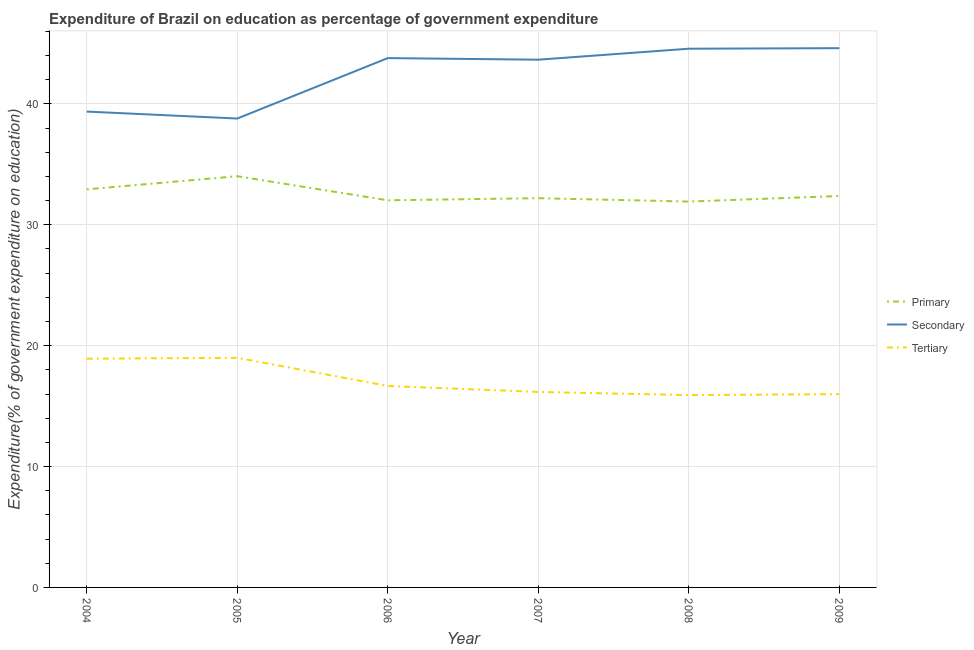What is the expenditure on secondary education in 2005?
Ensure brevity in your answer.  38.79. Across all years, what is the maximum expenditure on tertiary education?
Offer a very short reply. 19. Across all years, what is the minimum expenditure on tertiary education?
Give a very brief answer. 15.91. In which year was the expenditure on tertiary education maximum?
Provide a succinct answer. 2005. What is the total expenditure on primary education in the graph?
Provide a short and direct response. 195.47. What is the difference between the expenditure on primary education in 2005 and that in 2008?
Keep it short and to the point. 2.1. What is the difference between the expenditure on secondary education in 2004 and the expenditure on tertiary education in 2009?
Give a very brief answer. 23.37. What is the average expenditure on secondary education per year?
Offer a terse response. 42.46. In the year 2007, what is the difference between the expenditure on secondary education and expenditure on primary education?
Give a very brief answer. 11.46. What is the ratio of the expenditure on primary education in 2005 to that in 2008?
Offer a terse response. 1.07. Is the expenditure on primary education in 2004 less than that in 2008?
Provide a short and direct response. No. What is the difference between the highest and the second highest expenditure on primary education?
Make the answer very short. 1.08. What is the difference between the highest and the lowest expenditure on secondary education?
Provide a short and direct response. 5.82. In how many years, is the expenditure on secondary education greater than the average expenditure on secondary education taken over all years?
Offer a terse response. 4. Is it the case that in every year, the sum of the expenditure on primary education and expenditure on secondary education is greater than the expenditure on tertiary education?
Keep it short and to the point. Yes. Is the expenditure on tertiary education strictly greater than the expenditure on primary education over the years?
Provide a succinct answer. No. Is the expenditure on primary education strictly less than the expenditure on secondary education over the years?
Your answer should be compact. Yes. How many lines are there?
Keep it short and to the point. 3. How many years are there in the graph?
Your answer should be very brief. 6. Does the graph contain any zero values?
Your answer should be compact. No. How are the legend labels stacked?
Keep it short and to the point. Vertical. What is the title of the graph?
Give a very brief answer. Expenditure of Brazil on education as percentage of government expenditure. Does "Renewable sources" appear as one of the legend labels in the graph?
Your response must be concise. No. What is the label or title of the X-axis?
Your answer should be compact. Year. What is the label or title of the Y-axis?
Your response must be concise. Expenditure(% of government expenditure on education). What is the Expenditure(% of government expenditure on education) in Primary in 2004?
Ensure brevity in your answer.  32.93. What is the Expenditure(% of government expenditure on education) of Secondary in 2004?
Offer a terse response. 39.36. What is the Expenditure(% of government expenditure on education) of Tertiary in 2004?
Keep it short and to the point. 18.92. What is the Expenditure(% of government expenditure on education) in Primary in 2005?
Keep it short and to the point. 34.02. What is the Expenditure(% of government expenditure on education) of Secondary in 2005?
Your answer should be very brief. 38.79. What is the Expenditure(% of government expenditure on education) of Tertiary in 2005?
Provide a succinct answer. 19. What is the Expenditure(% of government expenditure on education) of Primary in 2006?
Offer a very short reply. 32.02. What is the Expenditure(% of government expenditure on education) of Secondary in 2006?
Ensure brevity in your answer.  43.79. What is the Expenditure(% of government expenditure on education) of Tertiary in 2006?
Ensure brevity in your answer.  16.66. What is the Expenditure(% of government expenditure on education) in Primary in 2007?
Ensure brevity in your answer.  32.2. What is the Expenditure(% of government expenditure on education) of Secondary in 2007?
Provide a short and direct response. 43.66. What is the Expenditure(% of government expenditure on education) of Tertiary in 2007?
Your response must be concise. 16.17. What is the Expenditure(% of government expenditure on education) in Primary in 2008?
Offer a terse response. 31.92. What is the Expenditure(% of government expenditure on education) of Secondary in 2008?
Give a very brief answer. 44.56. What is the Expenditure(% of government expenditure on education) of Tertiary in 2008?
Give a very brief answer. 15.91. What is the Expenditure(% of government expenditure on education) of Primary in 2009?
Your response must be concise. 32.38. What is the Expenditure(% of government expenditure on education) in Secondary in 2009?
Offer a terse response. 44.61. What is the Expenditure(% of government expenditure on education) in Tertiary in 2009?
Make the answer very short. 15.99. Across all years, what is the maximum Expenditure(% of government expenditure on education) in Primary?
Ensure brevity in your answer.  34.02. Across all years, what is the maximum Expenditure(% of government expenditure on education) of Secondary?
Keep it short and to the point. 44.61. Across all years, what is the maximum Expenditure(% of government expenditure on education) in Tertiary?
Provide a succinct answer. 19. Across all years, what is the minimum Expenditure(% of government expenditure on education) of Primary?
Offer a very short reply. 31.92. Across all years, what is the minimum Expenditure(% of government expenditure on education) in Secondary?
Offer a terse response. 38.79. Across all years, what is the minimum Expenditure(% of government expenditure on education) in Tertiary?
Your response must be concise. 15.91. What is the total Expenditure(% of government expenditure on education) of Primary in the graph?
Your response must be concise. 195.47. What is the total Expenditure(% of government expenditure on education) of Secondary in the graph?
Provide a short and direct response. 254.77. What is the total Expenditure(% of government expenditure on education) of Tertiary in the graph?
Provide a short and direct response. 102.65. What is the difference between the Expenditure(% of government expenditure on education) of Primary in 2004 and that in 2005?
Keep it short and to the point. -1.08. What is the difference between the Expenditure(% of government expenditure on education) in Secondary in 2004 and that in 2005?
Your answer should be compact. 0.57. What is the difference between the Expenditure(% of government expenditure on education) of Tertiary in 2004 and that in 2005?
Provide a short and direct response. -0.07. What is the difference between the Expenditure(% of government expenditure on education) in Primary in 2004 and that in 2006?
Offer a very short reply. 0.91. What is the difference between the Expenditure(% of government expenditure on education) in Secondary in 2004 and that in 2006?
Give a very brief answer. -4.42. What is the difference between the Expenditure(% of government expenditure on education) in Tertiary in 2004 and that in 2006?
Your answer should be compact. 2.26. What is the difference between the Expenditure(% of government expenditure on education) of Primary in 2004 and that in 2007?
Your answer should be very brief. 0.73. What is the difference between the Expenditure(% of government expenditure on education) in Secondary in 2004 and that in 2007?
Your answer should be very brief. -4.29. What is the difference between the Expenditure(% of government expenditure on education) of Tertiary in 2004 and that in 2007?
Offer a very short reply. 2.75. What is the difference between the Expenditure(% of government expenditure on education) in Primary in 2004 and that in 2008?
Keep it short and to the point. 1.01. What is the difference between the Expenditure(% of government expenditure on education) of Secondary in 2004 and that in 2008?
Offer a very short reply. -5.2. What is the difference between the Expenditure(% of government expenditure on education) in Tertiary in 2004 and that in 2008?
Provide a succinct answer. 3.01. What is the difference between the Expenditure(% of government expenditure on education) of Primary in 2004 and that in 2009?
Your answer should be compact. 0.55. What is the difference between the Expenditure(% of government expenditure on education) in Secondary in 2004 and that in 2009?
Provide a short and direct response. -5.25. What is the difference between the Expenditure(% of government expenditure on education) in Tertiary in 2004 and that in 2009?
Your answer should be very brief. 2.93. What is the difference between the Expenditure(% of government expenditure on education) in Primary in 2005 and that in 2006?
Provide a succinct answer. 1.99. What is the difference between the Expenditure(% of government expenditure on education) in Secondary in 2005 and that in 2006?
Offer a terse response. -5. What is the difference between the Expenditure(% of government expenditure on education) of Tertiary in 2005 and that in 2006?
Ensure brevity in your answer.  2.33. What is the difference between the Expenditure(% of government expenditure on education) of Primary in 2005 and that in 2007?
Provide a succinct answer. 1.82. What is the difference between the Expenditure(% of government expenditure on education) in Secondary in 2005 and that in 2007?
Keep it short and to the point. -4.87. What is the difference between the Expenditure(% of government expenditure on education) of Tertiary in 2005 and that in 2007?
Provide a short and direct response. 2.82. What is the difference between the Expenditure(% of government expenditure on education) in Primary in 2005 and that in 2008?
Ensure brevity in your answer.  2.1. What is the difference between the Expenditure(% of government expenditure on education) in Secondary in 2005 and that in 2008?
Offer a very short reply. -5.78. What is the difference between the Expenditure(% of government expenditure on education) in Tertiary in 2005 and that in 2008?
Make the answer very short. 3.08. What is the difference between the Expenditure(% of government expenditure on education) of Primary in 2005 and that in 2009?
Provide a short and direct response. 1.64. What is the difference between the Expenditure(% of government expenditure on education) of Secondary in 2005 and that in 2009?
Provide a short and direct response. -5.82. What is the difference between the Expenditure(% of government expenditure on education) of Tertiary in 2005 and that in 2009?
Your answer should be very brief. 3.01. What is the difference between the Expenditure(% of government expenditure on education) in Primary in 2006 and that in 2007?
Make the answer very short. -0.17. What is the difference between the Expenditure(% of government expenditure on education) in Secondary in 2006 and that in 2007?
Give a very brief answer. 0.13. What is the difference between the Expenditure(% of government expenditure on education) in Tertiary in 2006 and that in 2007?
Your answer should be very brief. 0.49. What is the difference between the Expenditure(% of government expenditure on education) in Primary in 2006 and that in 2008?
Your response must be concise. 0.11. What is the difference between the Expenditure(% of government expenditure on education) of Secondary in 2006 and that in 2008?
Provide a succinct answer. -0.78. What is the difference between the Expenditure(% of government expenditure on education) in Tertiary in 2006 and that in 2008?
Ensure brevity in your answer.  0.75. What is the difference between the Expenditure(% of government expenditure on education) of Primary in 2006 and that in 2009?
Your answer should be very brief. -0.35. What is the difference between the Expenditure(% of government expenditure on education) of Secondary in 2006 and that in 2009?
Make the answer very short. -0.82. What is the difference between the Expenditure(% of government expenditure on education) of Tertiary in 2006 and that in 2009?
Keep it short and to the point. 0.68. What is the difference between the Expenditure(% of government expenditure on education) in Primary in 2007 and that in 2008?
Offer a very short reply. 0.28. What is the difference between the Expenditure(% of government expenditure on education) of Secondary in 2007 and that in 2008?
Keep it short and to the point. -0.91. What is the difference between the Expenditure(% of government expenditure on education) in Tertiary in 2007 and that in 2008?
Ensure brevity in your answer.  0.26. What is the difference between the Expenditure(% of government expenditure on education) of Primary in 2007 and that in 2009?
Keep it short and to the point. -0.18. What is the difference between the Expenditure(% of government expenditure on education) of Secondary in 2007 and that in 2009?
Offer a very short reply. -0.95. What is the difference between the Expenditure(% of government expenditure on education) in Tertiary in 2007 and that in 2009?
Your answer should be very brief. 0.18. What is the difference between the Expenditure(% of government expenditure on education) of Primary in 2008 and that in 2009?
Give a very brief answer. -0.46. What is the difference between the Expenditure(% of government expenditure on education) of Secondary in 2008 and that in 2009?
Provide a succinct answer. -0.04. What is the difference between the Expenditure(% of government expenditure on education) in Tertiary in 2008 and that in 2009?
Offer a terse response. -0.08. What is the difference between the Expenditure(% of government expenditure on education) of Primary in 2004 and the Expenditure(% of government expenditure on education) of Secondary in 2005?
Ensure brevity in your answer.  -5.86. What is the difference between the Expenditure(% of government expenditure on education) in Primary in 2004 and the Expenditure(% of government expenditure on education) in Tertiary in 2005?
Offer a very short reply. 13.94. What is the difference between the Expenditure(% of government expenditure on education) of Secondary in 2004 and the Expenditure(% of government expenditure on education) of Tertiary in 2005?
Provide a short and direct response. 20.37. What is the difference between the Expenditure(% of government expenditure on education) in Primary in 2004 and the Expenditure(% of government expenditure on education) in Secondary in 2006?
Give a very brief answer. -10.86. What is the difference between the Expenditure(% of government expenditure on education) of Primary in 2004 and the Expenditure(% of government expenditure on education) of Tertiary in 2006?
Offer a terse response. 16.27. What is the difference between the Expenditure(% of government expenditure on education) of Secondary in 2004 and the Expenditure(% of government expenditure on education) of Tertiary in 2006?
Your answer should be compact. 22.7. What is the difference between the Expenditure(% of government expenditure on education) in Primary in 2004 and the Expenditure(% of government expenditure on education) in Secondary in 2007?
Offer a very short reply. -10.72. What is the difference between the Expenditure(% of government expenditure on education) of Primary in 2004 and the Expenditure(% of government expenditure on education) of Tertiary in 2007?
Ensure brevity in your answer.  16.76. What is the difference between the Expenditure(% of government expenditure on education) in Secondary in 2004 and the Expenditure(% of government expenditure on education) in Tertiary in 2007?
Make the answer very short. 23.19. What is the difference between the Expenditure(% of government expenditure on education) in Primary in 2004 and the Expenditure(% of government expenditure on education) in Secondary in 2008?
Offer a terse response. -11.63. What is the difference between the Expenditure(% of government expenditure on education) of Primary in 2004 and the Expenditure(% of government expenditure on education) of Tertiary in 2008?
Keep it short and to the point. 17.02. What is the difference between the Expenditure(% of government expenditure on education) in Secondary in 2004 and the Expenditure(% of government expenditure on education) in Tertiary in 2008?
Your response must be concise. 23.45. What is the difference between the Expenditure(% of government expenditure on education) of Primary in 2004 and the Expenditure(% of government expenditure on education) of Secondary in 2009?
Your response must be concise. -11.68. What is the difference between the Expenditure(% of government expenditure on education) of Primary in 2004 and the Expenditure(% of government expenditure on education) of Tertiary in 2009?
Offer a terse response. 16.94. What is the difference between the Expenditure(% of government expenditure on education) of Secondary in 2004 and the Expenditure(% of government expenditure on education) of Tertiary in 2009?
Your answer should be very brief. 23.37. What is the difference between the Expenditure(% of government expenditure on education) of Primary in 2005 and the Expenditure(% of government expenditure on education) of Secondary in 2006?
Make the answer very short. -9.77. What is the difference between the Expenditure(% of government expenditure on education) of Primary in 2005 and the Expenditure(% of government expenditure on education) of Tertiary in 2006?
Ensure brevity in your answer.  17.35. What is the difference between the Expenditure(% of government expenditure on education) in Secondary in 2005 and the Expenditure(% of government expenditure on education) in Tertiary in 2006?
Your answer should be very brief. 22.12. What is the difference between the Expenditure(% of government expenditure on education) of Primary in 2005 and the Expenditure(% of government expenditure on education) of Secondary in 2007?
Your answer should be very brief. -9.64. What is the difference between the Expenditure(% of government expenditure on education) of Primary in 2005 and the Expenditure(% of government expenditure on education) of Tertiary in 2007?
Your answer should be compact. 17.84. What is the difference between the Expenditure(% of government expenditure on education) of Secondary in 2005 and the Expenditure(% of government expenditure on education) of Tertiary in 2007?
Keep it short and to the point. 22.62. What is the difference between the Expenditure(% of government expenditure on education) in Primary in 2005 and the Expenditure(% of government expenditure on education) in Secondary in 2008?
Make the answer very short. -10.55. What is the difference between the Expenditure(% of government expenditure on education) in Primary in 2005 and the Expenditure(% of government expenditure on education) in Tertiary in 2008?
Offer a terse response. 18.11. What is the difference between the Expenditure(% of government expenditure on education) of Secondary in 2005 and the Expenditure(% of government expenditure on education) of Tertiary in 2008?
Offer a very short reply. 22.88. What is the difference between the Expenditure(% of government expenditure on education) of Primary in 2005 and the Expenditure(% of government expenditure on education) of Secondary in 2009?
Provide a succinct answer. -10.59. What is the difference between the Expenditure(% of government expenditure on education) in Primary in 2005 and the Expenditure(% of government expenditure on education) in Tertiary in 2009?
Make the answer very short. 18.03. What is the difference between the Expenditure(% of government expenditure on education) of Secondary in 2005 and the Expenditure(% of government expenditure on education) of Tertiary in 2009?
Your response must be concise. 22.8. What is the difference between the Expenditure(% of government expenditure on education) of Primary in 2006 and the Expenditure(% of government expenditure on education) of Secondary in 2007?
Your answer should be very brief. -11.63. What is the difference between the Expenditure(% of government expenditure on education) in Primary in 2006 and the Expenditure(% of government expenditure on education) in Tertiary in 2007?
Provide a succinct answer. 15.85. What is the difference between the Expenditure(% of government expenditure on education) in Secondary in 2006 and the Expenditure(% of government expenditure on education) in Tertiary in 2007?
Ensure brevity in your answer.  27.62. What is the difference between the Expenditure(% of government expenditure on education) in Primary in 2006 and the Expenditure(% of government expenditure on education) in Secondary in 2008?
Make the answer very short. -12.54. What is the difference between the Expenditure(% of government expenditure on education) in Primary in 2006 and the Expenditure(% of government expenditure on education) in Tertiary in 2008?
Your answer should be compact. 16.11. What is the difference between the Expenditure(% of government expenditure on education) of Secondary in 2006 and the Expenditure(% of government expenditure on education) of Tertiary in 2008?
Offer a terse response. 27.88. What is the difference between the Expenditure(% of government expenditure on education) in Primary in 2006 and the Expenditure(% of government expenditure on education) in Secondary in 2009?
Give a very brief answer. -12.58. What is the difference between the Expenditure(% of government expenditure on education) of Primary in 2006 and the Expenditure(% of government expenditure on education) of Tertiary in 2009?
Keep it short and to the point. 16.04. What is the difference between the Expenditure(% of government expenditure on education) of Secondary in 2006 and the Expenditure(% of government expenditure on education) of Tertiary in 2009?
Offer a terse response. 27.8. What is the difference between the Expenditure(% of government expenditure on education) in Primary in 2007 and the Expenditure(% of government expenditure on education) in Secondary in 2008?
Your answer should be very brief. -12.37. What is the difference between the Expenditure(% of government expenditure on education) in Primary in 2007 and the Expenditure(% of government expenditure on education) in Tertiary in 2008?
Offer a very short reply. 16.29. What is the difference between the Expenditure(% of government expenditure on education) in Secondary in 2007 and the Expenditure(% of government expenditure on education) in Tertiary in 2008?
Provide a succinct answer. 27.75. What is the difference between the Expenditure(% of government expenditure on education) of Primary in 2007 and the Expenditure(% of government expenditure on education) of Secondary in 2009?
Make the answer very short. -12.41. What is the difference between the Expenditure(% of government expenditure on education) in Primary in 2007 and the Expenditure(% of government expenditure on education) in Tertiary in 2009?
Provide a succinct answer. 16.21. What is the difference between the Expenditure(% of government expenditure on education) of Secondary in 2007 and the Expenditure(% of government expenditure on education) of Tertiary in 2009?
Give a very brief answer. 27.67. What is the difference between the Expenditure(% of government expenditure on education) in Primary in 2008 and the Expenditure(% of government expenditure on education) in Secondary in 2009?
Ensure brevity in your answer.  -12.69. What is the difference between the Expenditure(% of government expenditure on education) in Primary in 2008 and the Expenditure(% of government expenditure on education) in Tertiary in 2009?
Provide a short and direct response. 15.93. What is the difference between the Expenditure(% of government expenditure on education) of Secondary in 2008 and the Expenditure(% of government expenditure on education) of Tertiary in 2009?
Provide a short and direct response. 28.58. What is the average Expenditure(% of government expenditure on education) in Primary per year?
Offer a terse response. 32.58. What is the average Expenditure(% of government expenditure on education) of Secondary per year?
Make the answer very short. 42.46. What is the average Expenditure(% of government expenditure on education) of Tertiary per year?
Give a very brief answer. 17.11. In the year 2004, what is the difference between the Expenditure(% of government expenditure on education) in Primary and Expenditure(% of government expenditure on education) in Secondary?
Make the answer very short. -6.43. In the year 2004, what is the difference between the Expenditure(% of government expenditure on education) of Primary and Expenditure(% of government expenditure on education) of Tertiary?
Offer a terse response. 14.01. In the year 2004, what is the difference between the Expenditure(% of government expenditure on education) of Secondary and Expenditure(% of government expenditure on education) of Tertiary?
Your answer should be compact. 20.44. In the year 2005, what is the difference between the Expenditure(% of government expenditure on education) of Primary and Expenditure(% of government expenditure on education) of Secondary?
Provide a succinct answer. -4.77. In the year 2005, what is the difference between the Expenditure(% of government expenditure on education) in Primary and Expenditure(% of government expenditure on education) in Tertiary?
Your response must be concise. 15.02. In the year 2005, what is the difference between the Expenditure(% of government expenditure on education) of Secondary and Expenditure(% of government expenditure on education) of Tertiary?
Your answer should be very brief. 19.79. In the year 2006, what is the difference between the Expenditure(% of government expenditure on education) in Primary and Expenditure(% of government expenditure on education) in Secondary?
Provide a short and direct response. -11.76. In the year 2006, what is the difference between the Expenditure(% of government expenditure on education) in Primary and Expenditure(% of government expenditure on education) in Tertiary?
Make the answer very short. 15.36. In the year 2006, what is the difference between the Expenditure(% of government expenditure on education) in Secondary and Expenditure(% of government expenditure on education) in Tertiary?
Make the answer very short. 27.12. In the year 2007, what is the difference between the Expenditure(% of government expenditure on education) in Primary and Expenditure(% of government expenditure on education) in Secondary?
Your answer should be very brief. -11.46. In the year 2007, what is the difference between the Expenditure(% of government expenditure on education) of Primary and Expenditure(% of government expenditure on education) of Tertiary?
Provide a succinct answer. 16.03. In the year 2007, what is the difference between the Expenditure(% of government expenditure on education) of Secondary and Expenditure(% of government expenditure on education) of Tertiary?
Provide a short and direct response. 27.48. In the year 2008, what is the difference between the Expenditure(% of government expenditure on education) in Primary and Expenditure(% of government expenditure on education) in Secondary?
Keep it short and to the point. -12.64. In the year 2008, what is the difference between the Expenditure(% of government expenditure on education) of Primary and Expenditure(% of government expenditure on education) of Tertiary?
Your response must be concise. 16.01. In the year 2008, what is the difference between the Expenditure(% of government expenditure on education) in Secondary and Expenditure(% of government expenditure on education) in Tertiary?
Keep it short and to the point. 28.65. In the year 2009, what is the difference between the Expenditure(% of government expenditure on education) in Primary and Expenditure(% of government expenditure on education) in Secondary?
Your answer should be compact. -12.23. In the year 2009, what is the difference between the Expenditure(% of government expenditure on education) of Primary and Expenditure(% of government expenditure on education) of Tertiary?
Offer a terse response. 16.39. In the year 2009, what is the difference between the Expenditure(% of government expenditure on education) of Secondary and Expenditure(% of government expenditure on education) of Tertiary?
Keep it short and to the point. 28.62. What is the ratio of the Expenditure(% of government expenditure on education) in Primary in 2004 to that in 2005?
Your answer should be very brief. 0.97. What is the ratio of the Expenditure(% of government expenditure on education) of Secondary in 2004 to that in 2005?
Ensure brevity in your answer.  1.01. What is the ratio of the Expenditure(% of government expenditure on education) in Primary in 2004 to that in 2006?
Ensure brevity in your answer.  1.03. What is the ratio of the Expenditure(% of government expenditure on education) in Secondary in 2004 to that in 2006?
Offer a terse response. 0.9. What is the ratio of the Expenditure(% of government expenditure on education) of Tertiary in 2004 to that in 2006?
Ensure brevity in your answer.  1.14. What is the ratio of the Expenditure(% of government expenditure on education) of Primary in 2004 to that in 2007?
Offer a very short reply. 1.02. What is the ratio of the Expenditure(% of government expenditure on education) in Secondary in 2004 to that in 2007?
Ensure brevity in your answer.  0.9. What is the ratio of the Expenditure(% of government expenditure on education) in Tertiary in 2004 to that in 2007?
Give a very brief answer. 1.17. What is the ratio of the Expenditure(% of government expenditure on education) of Primary in 2004 to that in 2008?
Provide a succinct answer. 1.03. What is the ratio of the Expenditure(% of government expenditure on education) in Secondary in 2004 to that in 2008?
Offer a very short reply. 0.88. What is the ratio of the Expenditure(% of government expenditure on education) of Tertiary in 2004 to that in 2008?
Provide a succinct answer. 1.19. What is the ratio of the Expenditure(% of government expenditure on education) of Primary in 2004 to that in 2009?
Offer a terse response. 1.02. What is the ratio of the Expenditure(% of government expenditure on education) in Secondary in 2004 to that in 2009?
Give a very brief answer. 0.88. What is the ratio of the Expenditure(% of government expenditure on education) of Tertiary in 2004 to that in 2009?
Offer a terse response. 1.18. What is the ratio of the Expenditure(% of government expenditure on education) in Primary in 2005 to that in 2006?
Provide a succinct answer. 1.06. What is the ratio of the Expenditure(% of government expenditure on education) in Secondary in 2005 to that in 2006?
Provide a short and direct response. 0.89. What is the ratio of the Expenditure(% of government expenditure on education) in Tertiary in 2005 to that in 2006?
Give a very brief answer. 1.14. What is the ratio of the Expenditure(% of government expenditure on education) in Primary in 2005 to that in 2007?
Provide a short and direct response. 1.06. What is the ratio of the Expenditure(% of government expenditure on education) of Secondary in 2005 to that in 2007?
Provide a succinct answer. 0.89. What is the ratio of the Expenditure(% of government expenditure on education) in Tertiary in 2005 to that in 2007?
Give a very brief answer. 1.17. What is the ratio of the Expenditure(% of government expenditure on education) in Primary in 2005 to that in 2008?
Offer a very short reply. 1.07. What is the ratio of the Expenditure(% of government expenditure on education) in Secondary in 2005 to that in 2008?
Offer a terse response. 0.87. What is the ratio of the Expenditure(% of government expenditure on education) in Tertiary in 2005 to that in 2008?
Keep it short and to the point. 1.19. What is the ratio of the Expenditure(% of government expenditure on education) in Primary in 2005 to that in 2009?
Your answer should be compact. 1.05. What is the ratio of the Expenditure(% of government expenditure on education) of Secondary in 2005 to that in 2009?
Keep it short and to the point. 0.87. What is the ratio of the Expenditure(% of government expenditure on education) in Tertiary in 2005 to that in 2009?
Offer a very short reply. 1.19. What is the ratio of the Expenditure(% of government expenditure on education) in Primary in 2006 to that in 2007?
Keep it short and to the point. 0.99. What is the ratio of the Expenditure(% of government expenditure on education) of Tertiary in 2006 to that in 2007?
Keep it short and to the point. 1.03. What is the ratio of the Expenditure(% of government expenditure on education) of Primary in 2006 to that in 2008?
Your response must be concise. 1. What is the ratio of the Expenditure(% of government expenditure on education) in Secondary in 2006 to that in 2008?
Offer a terse response. 0.98. What is the ratio of the Expenditure(% of government expenditure on education) in Tertiary in 2006 to that in 2008?
Your response must be concise. 1.05. What is the ratio of the Expenditure(% of government expenditure on education) in Primary in 2006 to that in 2009?
Your answer should be compact. 0.99. What is the ratio of the Expenditure(% of government expenditure on education) in Secondary in 2006 to that in 2009?
Your answer should be compact. 0.98. What is the ratio of the Expenditure(% of government expenditure on education) of Tertiary in 2006 to that in 2009?
Provide a succinct answer. 1.04. What is the ratio of the Expenditure(% of government expenditure on education) of Primary in 2007 to that in 2008?
Provide a succinct answer. 1.01. What is the ratio of the Expenditure(% of government expenditure on education) of Secondary in 2007 to that in 2008?
Your answer should be very brief. 0.98. What is the ratio of the Expenditure(% of government expenditure on education) in Tertiary in 2007 to that in 2008?
Offer a terse response. 1.02. What is the ratio of the Expenditure(% of government expenditure on education) of Primary in 2007 to that in 2009?
Give a very brief answer. 0.99. What is the ratio of the Expenditure(% of government expenditure on education) in Secondary in 2007 to that in 2009?
Your answer should be compact. 0.98. What is the ratio of the Expenditure(% of government expenditure on education) in Tertiary in 2007 to that in 2009?
Provide a short and direct response. 1.01. What is the ratio of the Expenditure(% of government expenditure on education) in Primary in 2008 to that in 2009?
Give a very brief answer. 0.99. What is the difference between the highest and the second highest Expenditure(% of government expenditure on education) of Primary?
Offer a very short reply. 1.08. What is the difference between the highest and the second highest Expenditure(% of government expenditure on education) of Secondary?
Give a very brief answer. 0.04. What is the difference between the highest and the second highest Expenditure(% of government expenditure on education) of Tertiary?
Your answer should be very brief. 0.07. What is the difference between the highest and the lowest Expenditure(% of government expenditure on education) of Primary?
Offer a terse response. 2.1. What is the difference between the highest and the lowest Expenditure(% of government expenditure on education) in Secondary?
Offer a very short reply. 5.82. What is the difference between the highest and the lowest Expenditure(% of government expenditure on education) of Tertiary?
Make the answer very short. 3.08. 